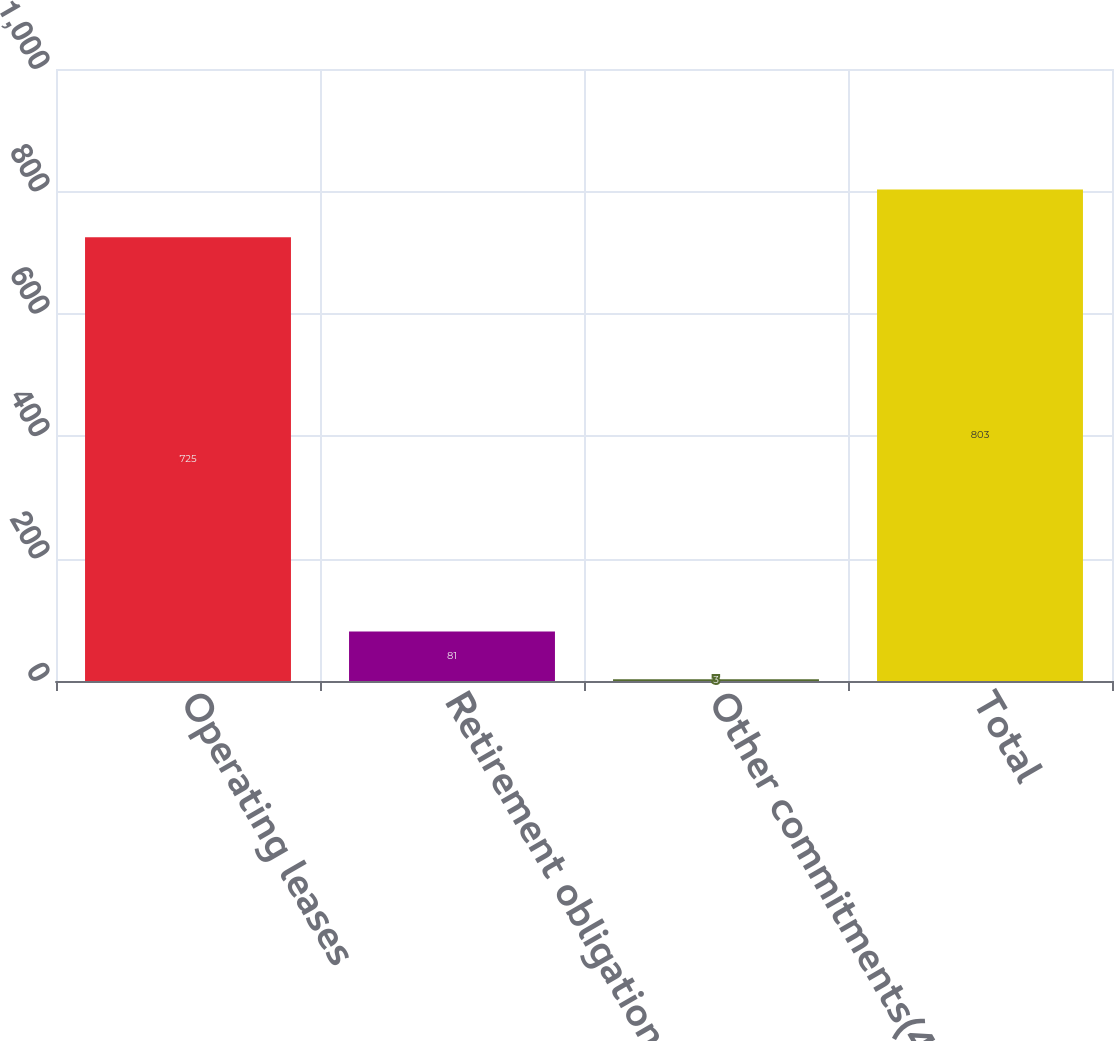Convert chart to OTSL. <chart><loc_0><loc_0><loc_500><loc_500><bar_chart><fcel>Operating leases<fcel>Retirement obligations(3)<fcel>Other commitments(4)<fcel>Total<nl><fcel>725<fcel>81<fcel>3<fcel>803<nl></chart> 